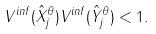Convert formula to latex. <formula><loc_0><loc_0><loc_500><loc_500>V ^ { i n f } ( \hat { X } _ { j } ^ { \theta } ) V ^ { i n f } ( \hat { Y } _ { j } ^ { \theta } ) < 1 .</formula> 